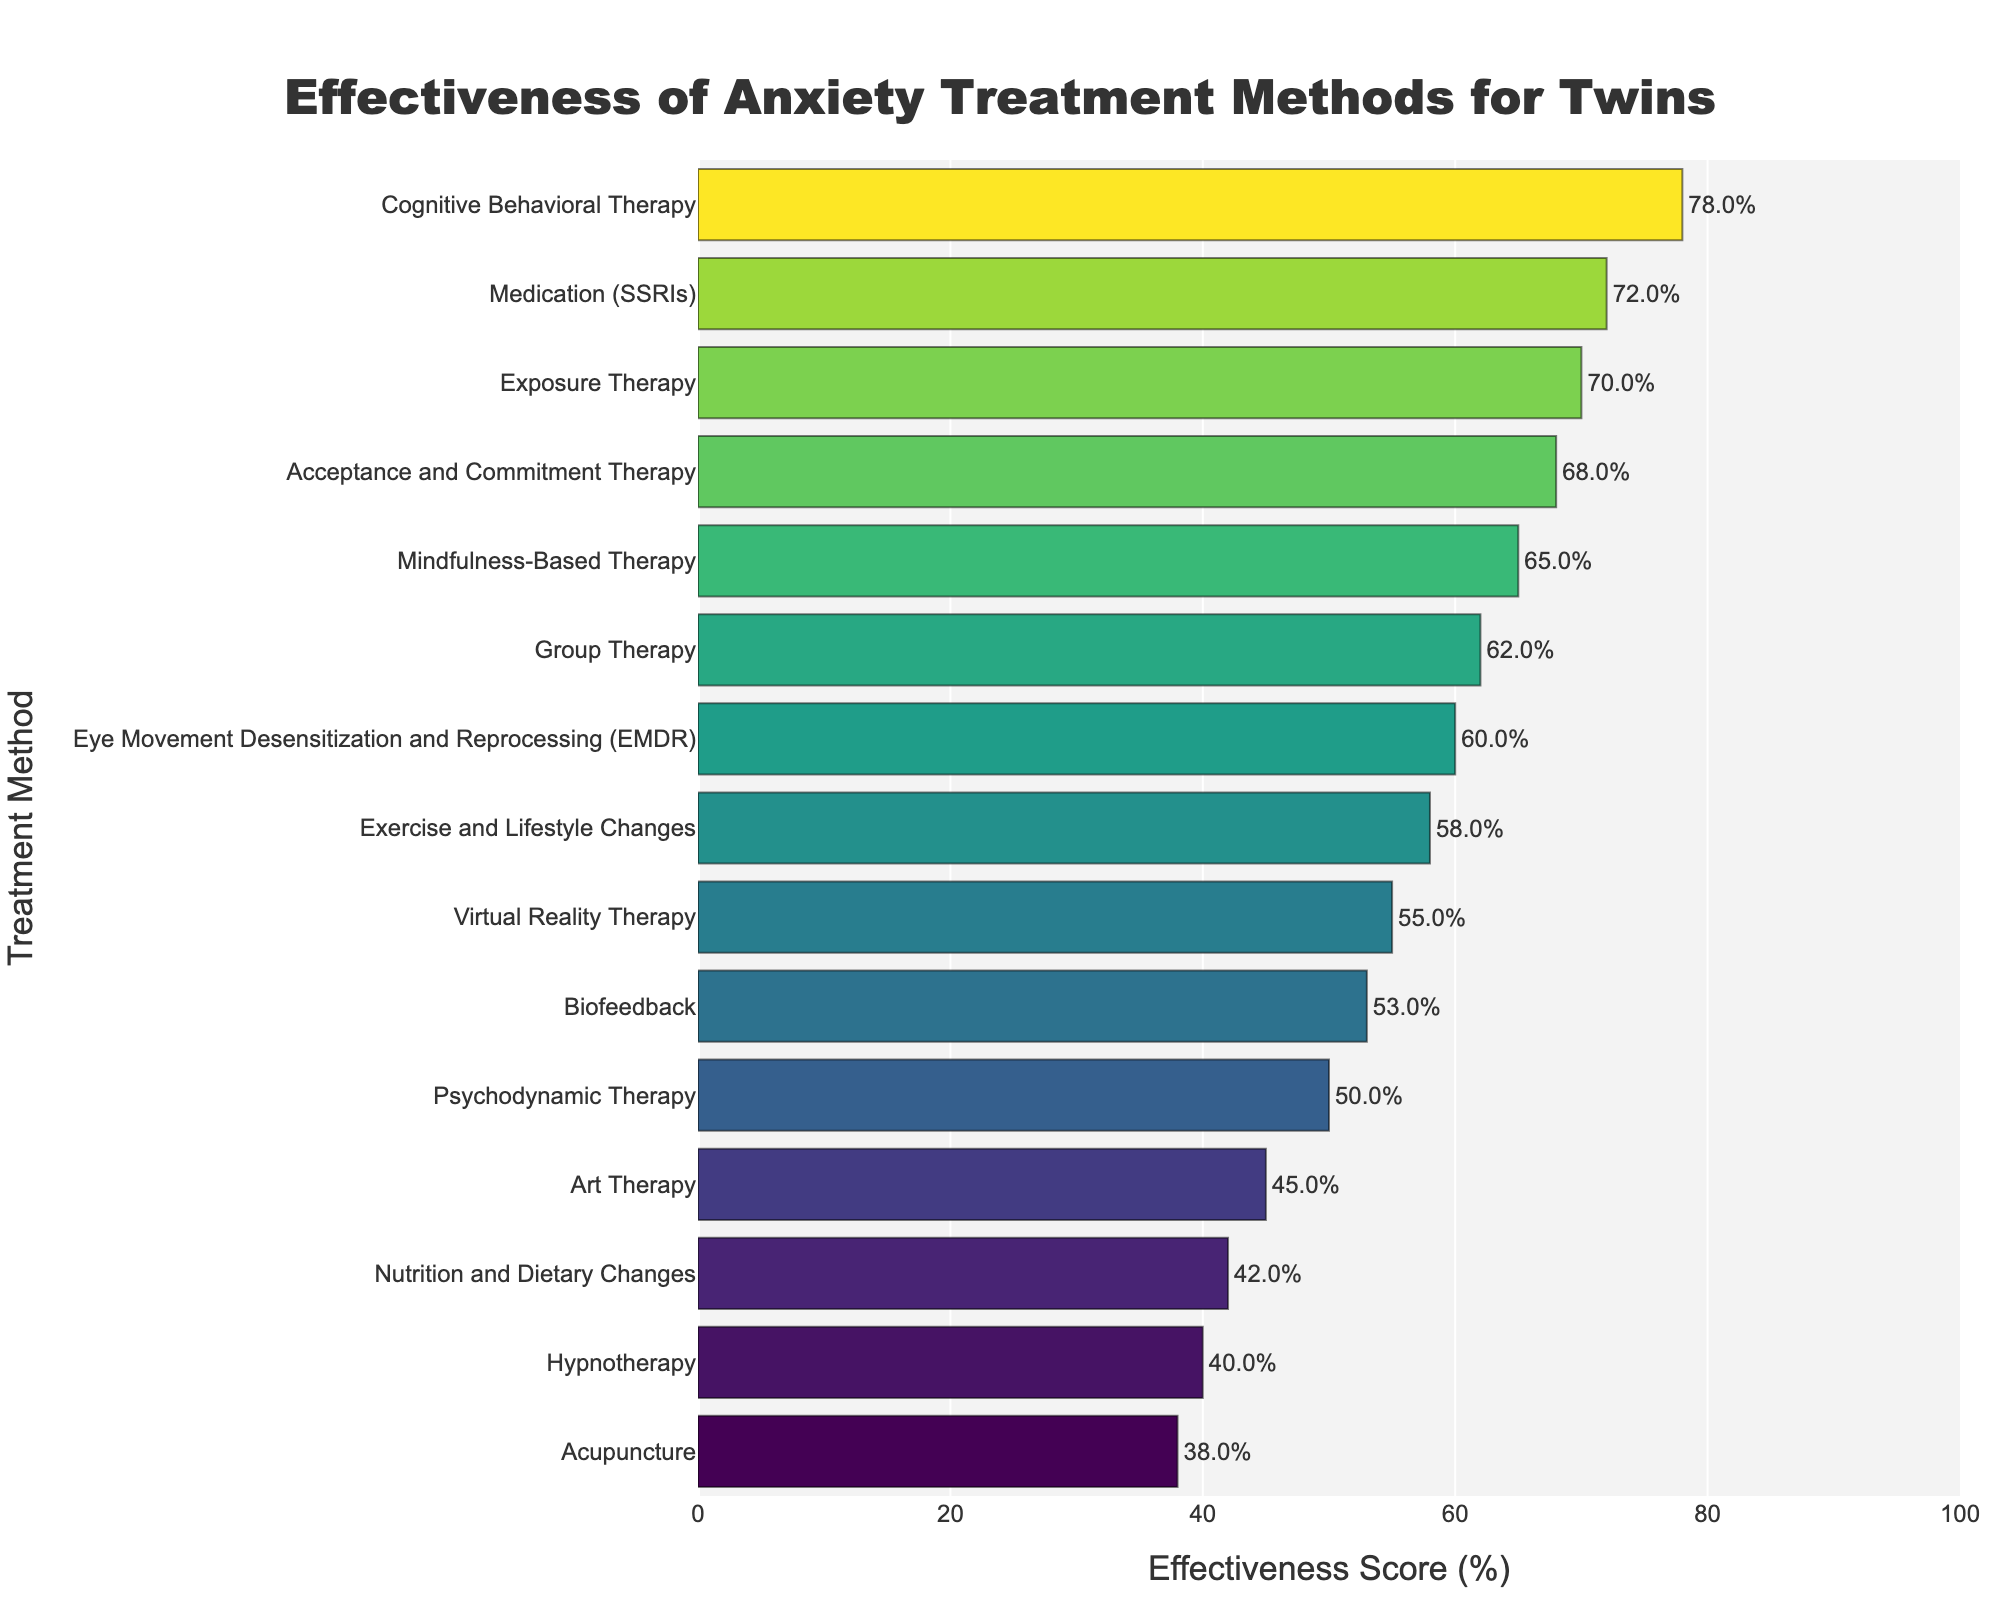What is the most effective treatment method for anxiety disorders in twins? To determine the most effective treatment method, look for the bar with the highest effectiveness score on the chart.
Answer: Cognitive Behavioral Therapy Which treatment method has the least effectiveness score? To identify the least effective treatment, find the bar with the lowest effectiveness score.
Answer: Acupuncture How much more effective is Cognitive Behavioral Therapy compared to Hypnotherapy? Find the effectiveness score of Cognitive Behavioral Therapy (78%) and Hypnotherapy (40%). Subtract the effectiveness score of Hypnotherapy from Cognitive Behavioral Therapy: 78% - 40% = 38%.
Answer: 38% Which treatments are more effective than Group Therapy? First, find the effectiveness score of Group Therapy (62%). Next, list treatment methods with higher effectiveness scores than 62%. These are Cognitive Behavioral Therapy (78%), Medication (SSRIs) (72%), Exposure Therapy (70%), Acceptance and Commitment Therapy (68%), and Mindfulness-Based Therapy (65%).
Answer: Cognitive Behavioral Therapy, Medication (SSRIs), Exposure Therapy, Acceptance and Commitment Therapy, Mindfulness-Based Therapy What is the average effectiveness score of the bottom three treatments? Identify the bottom three treatments: Acupuncture (38%), Hypnotherapy (40%), and Nutrition and Dietary Changes (42%). Calculate the average: (38% + 40% + 42%) / 3 = 40%.
Answer: 40% How does the effectiveness of Biofeedback compare to Psychodynamic Therapy? Look at the effectiveness scores of Biofeedback (53%) and Psychodynamic Therapy (50%). Biofeedback has a higher score by 3%.
Answer: Biofeedback is 3% more effective What is the combined effectiveness score of Mental Health Lifestyle Changes and Alternative Treatments (Exercise and Lifestyle Changes, Art Therapy, Virtual Reality Therapy, Biofeedback, Nutrition and Dietary Changes, Acupuncture)? List the effectiveness scores for each method: Exercise and Lifestyle Changes (58%), Art Therapy (45%), Virtual Reality Therapy (55%), Biofeedback (53%), Nutrition and Dietary Changes (42%), Acupuncture (38%). Sum these values: 58 + 45 + 55 + 53 + 42 + 38 = 291.
Answer: 291 Which treatment method appears in the middle if you rank all treatment methods by their effectiveness scores? Order all treatment methods and find the one at the median position (8th out of 15). The scores from lowest to highest are: Acupuncture (38%), Hypnotherapy (40%), Nutrition and Dietary Changes (42%), Art Therapy (45%), Psychodynamic Therapy (50%), Biofeedback (53%), Virtual Reality Therapy (55%), Eye Movement Desensitization and Reprocessing (EMDR) (60%), Group Therapy (62%), Exercise and Lifestyle Changes (58%), Mindfulness-Based Therapy (65%), Acceptance and Commitment Therapy (68%), Exposure Therapy (70%), Medication (SSRIs) (72%), Cognitive Behavioral Therapy (78%). The 8th treatment is Eye Movement Desensitization and Reprocessing (EMDR).
Answer: Eye Movement Desensitization and Reprocessing (EMDR) Which treatment methods have an effectiveness score within 10% of Cognitive Behavioral Therapy? Find the treatments whose effectiveness scores are between 68% and 88%. These methods are Cognitive Behavioral Therapy (78%), Medication (SSRIs) (72%), Exposure Therapy (70%), and Acceptance and Commitment Therapy (68%).
Answer: Medication (SSRIs), Exposure Therapy, Acceptance and Commitment Therapy 